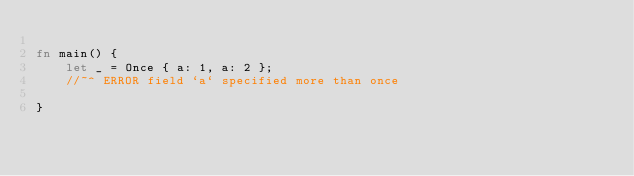<code> <loc_0><loc_0><loc_500><loc_500><_Rust_>
fn main() {
    let _ = Once { a: 1, a: 2 };
    //~^ ERROR field `a` specified more than once

}
</code> 